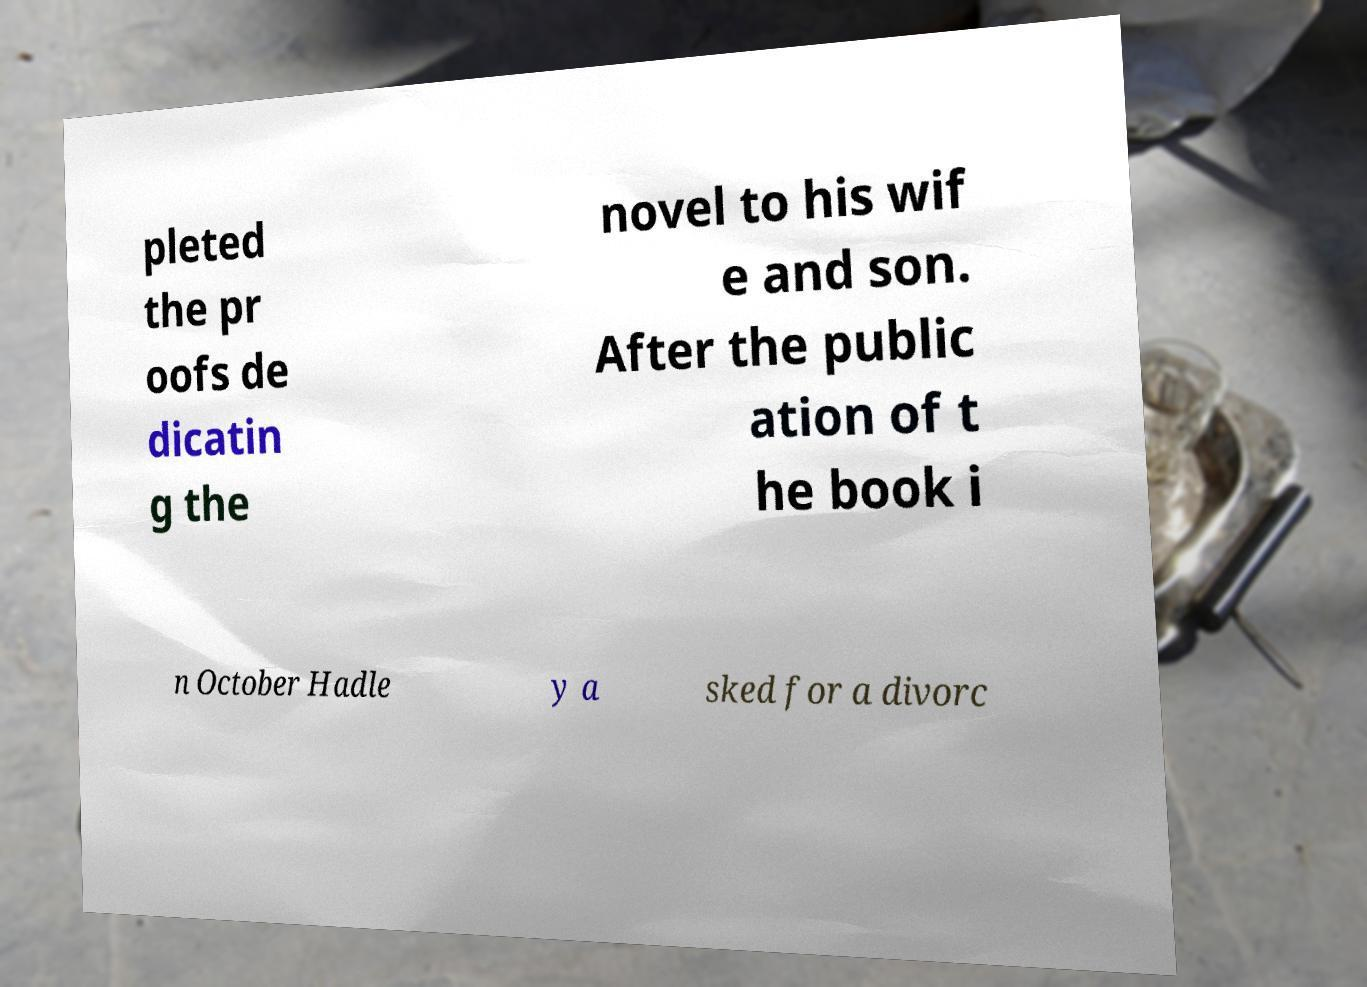Can you accurately transcribe the text from the provided image for me? pleted the pr oofs de dicatin g the novel to his wif e and son. After the public ation of t he book i n October Hadle y a sked for a divorc 